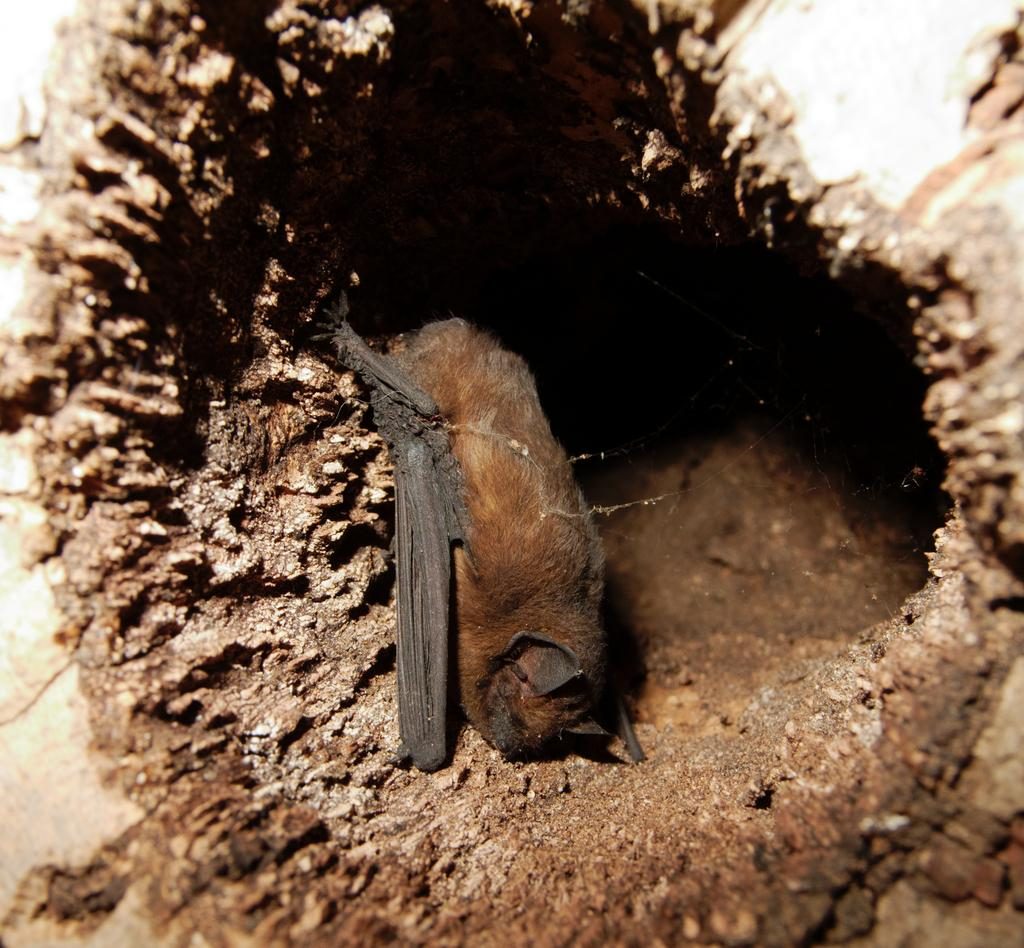What type of animal can be seen in the image? There is an animal in the image that looks like a bat. Where is the animal located in the image? The animal is on the ground in the image. What type of science experiment is being conducted with the bat in the image? There is no indication of a science experiment in the image; it simply shows a bat on the ground. 